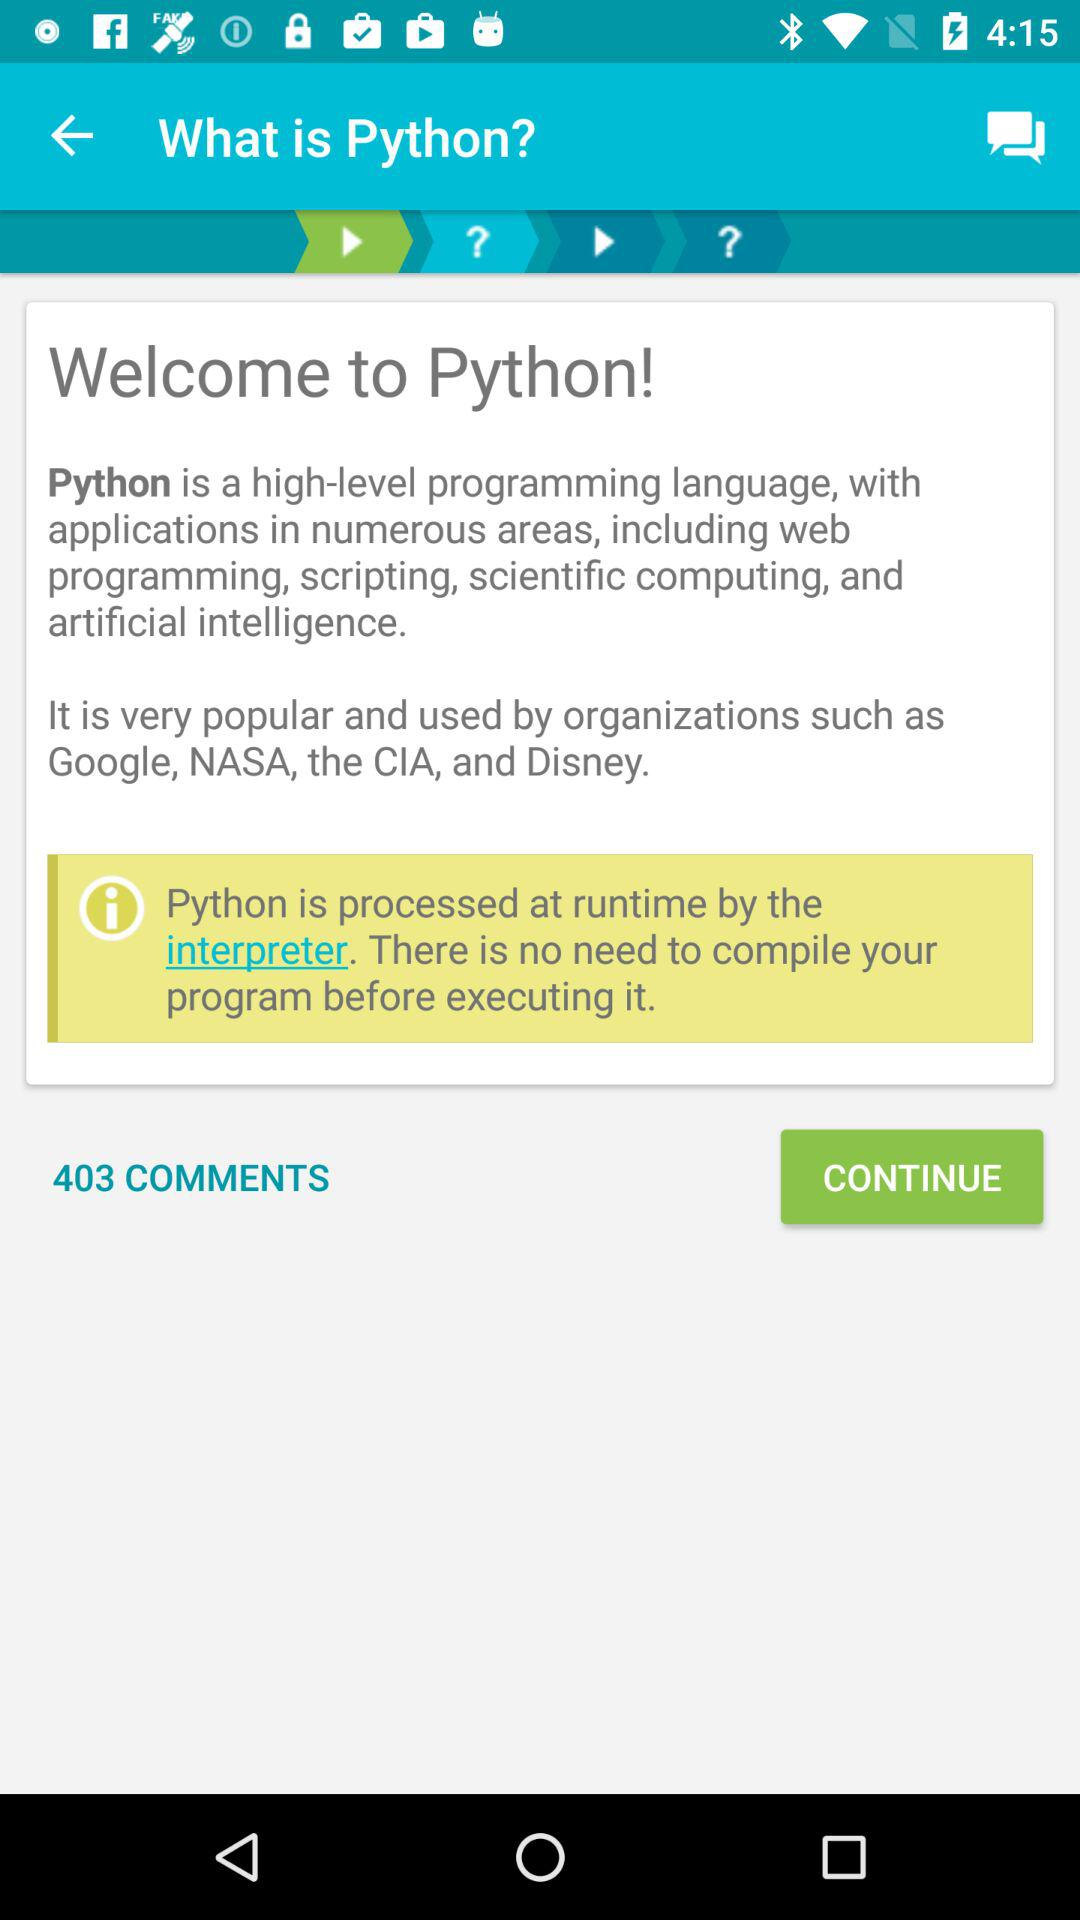In which organizations is "Python" used? "Python" is used in "Google", "NASA", the "CIA" and "Disney". 